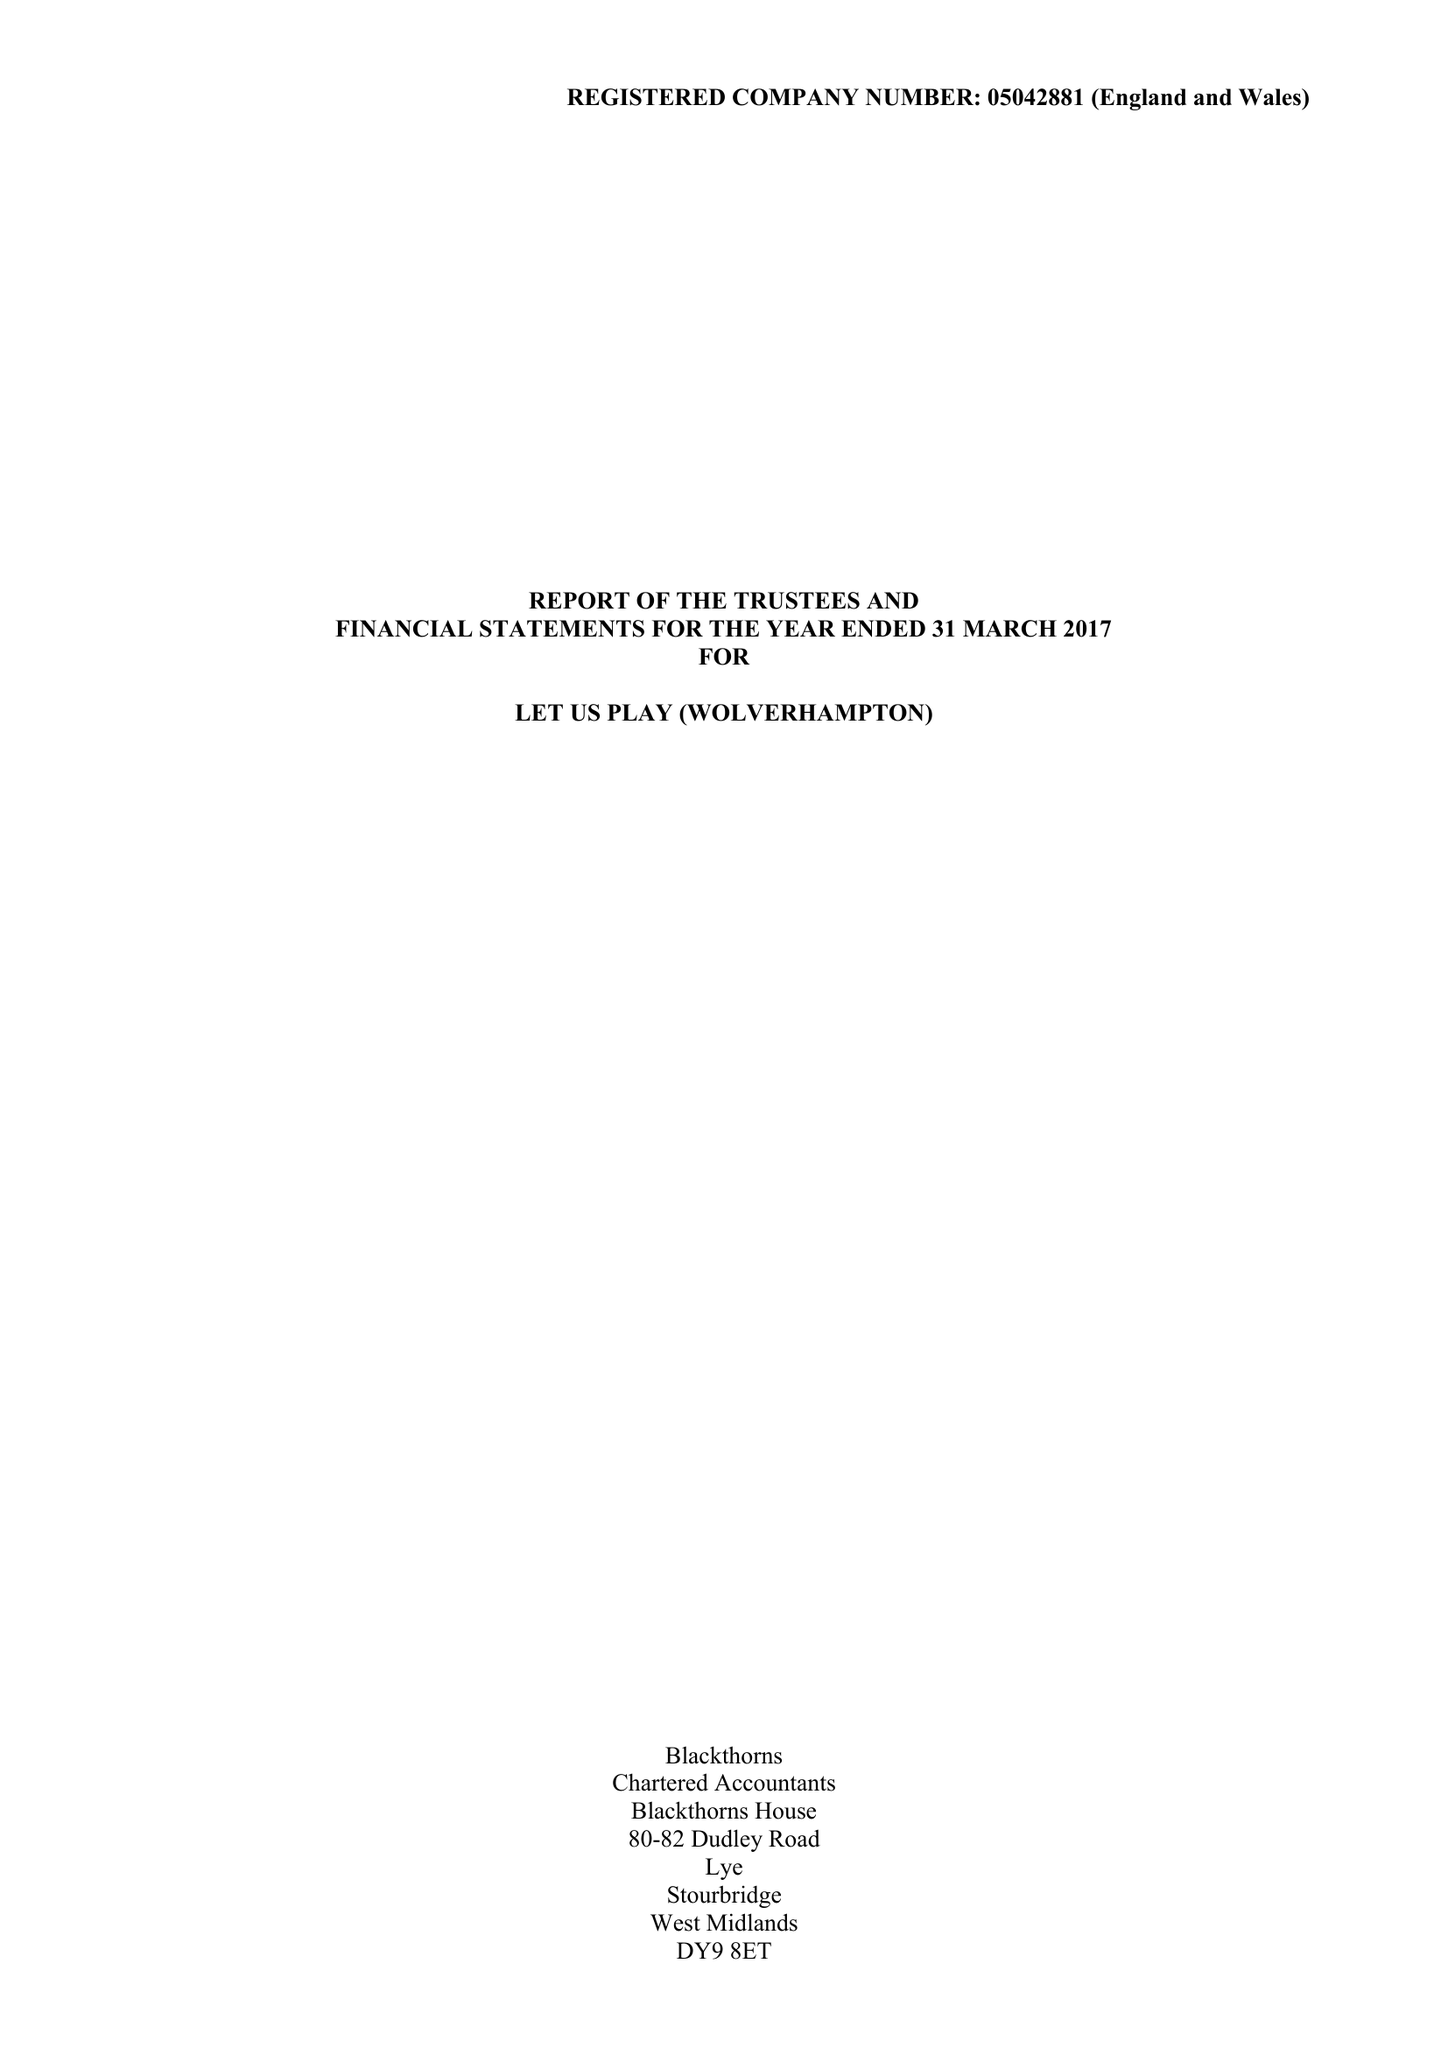What is the value for the charity_number?
Answer the question using a single word or phrase. 1104506 